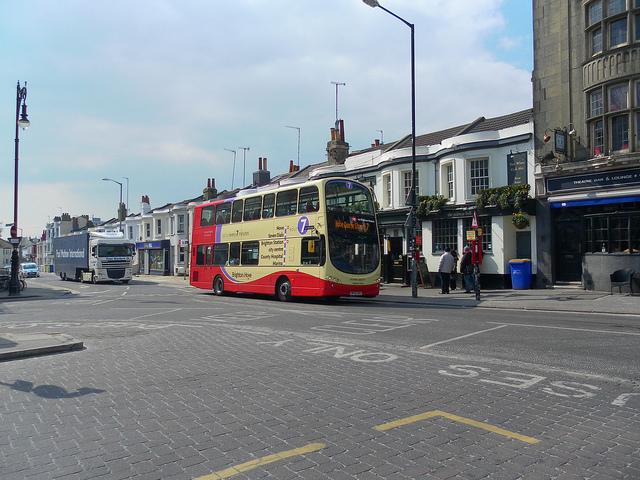How many trucks do you see?
Short answer required. 1. How many levels does this bus have?
Be succinct. 2. Is this a blue bus?
Short answer required. No. Are all the houses white?
Concise answer only. No. What color is the bus?
Answer briefly. Yellow and red. Is the sun setting?
Keep it brief. No. Could this be in Great Britain?
Be succinct. Yes. Is the bus parked in front of someone's house?
Concise answer only. No. Is it nighttime?
Keep it brief. No. 